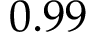<formula> <loc_0><loc_0><loc_500><loc_500>0 . 9 9</formula> 